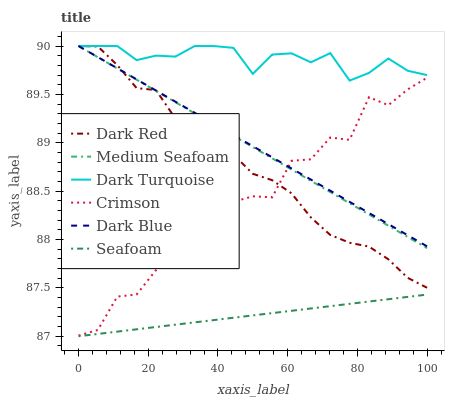Does Seafoam have the minimum area under the curve?
Answer yes or no. Yes. Does Dark Turquoise have the maximum area under the curve?
Answer yes or no. Yes. Does Dark Blue have the minimum area under the curve?
Answer yes or no. No. Does Dark Blue have the maximum area under the curve?
Answer yes or no. No. Is Seafoam the smoothest?
Answer yes or no. Yes. Is Crimson the roughest?
Answer yes or no. Yes. Is Dark Blue the smoothest?
Answer yes or no. No. Is Dark Blue the roughest?
Answer yes or no. No. Does Dark Blue have the lowest value?
Answer yes or no. No. Does Medium Seafoam have the highest value?
Answer yes or no. Yes. Does Seafoam have the highest value?
Answer yes or no. No. Is Seafoam less than Dark Turquoise?
Answer yes or no. Yes. Is Dark Red greater than Seafoam?
Answer yes or no. Yes. Does Seafoam intersect Dark Turquoise?
Answer yes or no. No. 